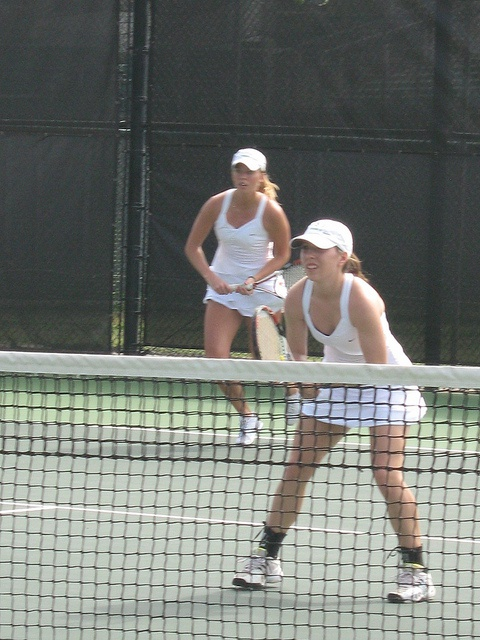Describe the objects in this image and their specific colors. I can see people in black, darkgray, lightgray, and gray tones, people in black, gray, and darkgray tones, tennis racket in black, tan, gray, darkgray, and lightgray tones, and tennis racket in black, darkgray, lightgray, and gray tones in this image. 